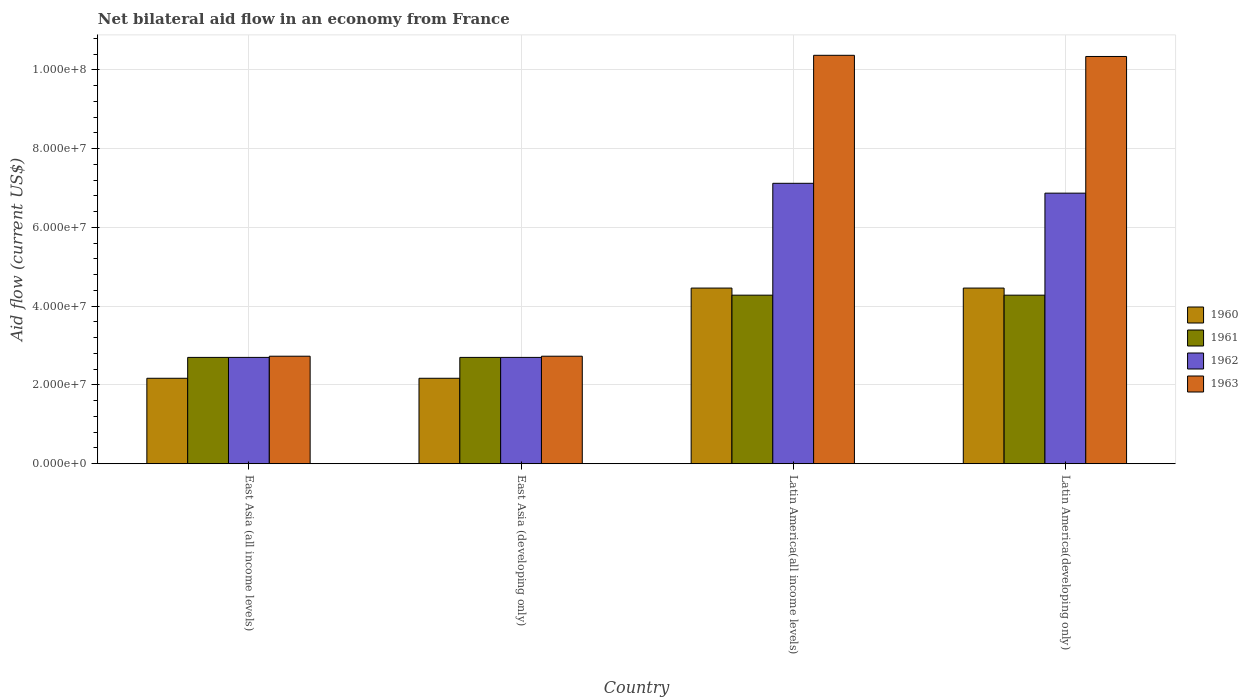How many different coloured bars are there?
Keep it short and to the point. 4. How many groups of bars are there?
Your answer should be compact. 4. Are the number of bars per tick equal to the number of legend labels?
Keep it short and to the point. Yes. How many bars are there on the 3rd tick from the left?
Offer a very short reply. 4. How many bars are there on the 4th tick from the right?
Your response must be concise. 4. What is the label of the 1st group of bars from the left?
Your answer should be very brief. East Asia (all income levels). In how many cases, is the number of bars for a given country not equal to the number of legend labels?
Offer a terse response. 0. What is the net bilateral aid flow in 1963 in Latin America(all income levels)?
Give a very brief answer. 1.04e+08. Across all countries, what is the maximum net bilateral aid flow in 1963?
Your answer should be very brief. 1.04e+08. Across all countries, what is the minimum net bilateral aid flow in 1962?
Your answer should be compact. 2.70e+07. In which country was the net bilateral aid flow in 1960 maximum?
Offer a terse response. Latin America(all income levels). In which country was the net bilateral aid flow in 1960 minimum?
Your answer should be very brief. East Asia (all income levels). What is the total net bilateral aid flow in 1961 in the graph?
Provide a succinct answer. 1.40e+08. What is the difference between the net bilateral aid flow in 1963 in East Asia (developing only) and that in Latin America(all income levels)?
Offer a very short reply. -7.64e+07. What is the difference between the net bilateral aid flow in 1960 in East Asia (developing only) and the net bilateral aid flow in 1961 in Latin America(developing only)?
Give a very brief answer. -2.11e+07. What is the average net bilateral aid flow in 1961 per country?
Your answer should be very brief. 3.49e+07. What is the difference between the net bilateral aid flow of/in 1960 and net bilateral aid flow of/in 1961 in Latin America(developing only)?
Provide a succinct answer. 1.80e+06. In how many countries, is the net bilateral aid flow in 1960 greater than 32000000 US$?
Provide a short and direct response. 2. What is the ratio of the net bilateral aid flow in 1960 in East Asia (developing only) to that in Latin America(all income levels)?
Your response must be concise. 0.49. Is the net bilateral aid flow in 1960 in East Asia (all income levels) less than that in Latin America(developing only)?
Make the answer very short. Yes. What is the difference between the highest and the second highest net bilateral aid flow in 1961?
Make the answer very short. 1.58e+07. What is the difference between the highest and the lowest net bilateral aid flow in 1963?
Offer a terse response. 7.64e+07. Is the sum of the net bilateral aid flow in 1960 in East Asia (developing only) and Latin America(all income levels) greater than the maximum net bilateral aid flow in 1962 across all countries?
Keep it short and to the point. No. Is it the case that in every country, the sum of the net bilateral aid flow in 1963 and net bilateral aid flow in 1962 is greater than the net bilateral aid flow in 1960?
Your response must be concise. Yes. Are all the bars in the graph horizontal?
Your response must be concise. No. How many countries are there in the graph?
Offer a terse response. 4. Are the values on the major ticks of Y-axis written in scientific E-notation?
Offer a terse response. Yes. Does the graph contain grids?
Your response must be concise. Yes. Where does the legend appear in the graph?
Provide a short and direct response. Center right. How many legend labels are there?
Keep it short and to the point. 4. What is the title of the graph?
Provide a succinct answer. Net bilateral aid flow in an economy from France. What is the label or title of the X-axis?
Ensure brevity in your answer.  Country. What is the Aid flow (current US$) in 1960 in East Asia (all income levels)?
Provide a succinct answer. 2.17e+07. What is the Aid flow (current US$) in 1961 in East Asia (all income levels)?
Provide a succinct answer. 2.70e+07. What is the Aid flow (current US$) of 1962 in East Asia (all income levels)?
Keep it short and to the point. 2.70e+07. What is the Aid flow (current US$) in 1963 in East Asia (all income levels)?
Provide a succinct answer. 2.73e+07. What is the Aid flow (current US$) in 1960 in East Asia (developing only)?
Offer a very short reply. 2.17e+07. What is the Aid flow (current US$) in 1961 in East Asia (developing only)?
Provide a short and direct response. 2.70e+07. What is the Aid flow (current US$) in 1962 in East Asia (developing only)?
Provide a short and direct response. 2.70e+07. What is the Aid flow (current US$) of 1963 in East Asia (developing only)?
Provide a succinct answer. 2.73e+07. What is the Aid flow (current US$) in 1960 in Latin America(all income levels)?
Offer a terse response. 4.46e+07. What is the Aid flow (current US$) of 1961 in Latin America(all income levels)?
Offer a terse response. 4.28e+07. What is the Aid flow (current US$) in 1962 in Latin America(all income levels)?
Make the answer very short. 7.12e+07. What is the Aid flow (current US$) of 1963 in Latin America(all income levels)?
Ensure brevity in your answer.  1.04e+08. What is the Aid flow (current US$) of 1960 in Latin America(developing only)?
Your response must be concise. 4.46e+07. What is the Aid flow (current US$) of 1961 in Latin America(developing only)?
Your response must be concise. 4.28e+07. What is the Aid flow (current US$) in 1962 in Latin America(developing only)?
Provide a short and direct response. 6.87e+07. What is the Aid flow (current US$) in 1963 in Latin America(developing only)?
Give a very brief answer. 1.03e+08. Across all countries, what is the maximum Aid flow (current US$) in 1960?
Your answer should be very brief. 4.46e+07. Across all countries, what is the maximum Aid flow (current US$) in 1961?
Provide a succinct answer. 4.28e+07. Across all countries, what is the maximum Aid flow (current US$) in 1962?
Provide a succinct answer. 7.12e+07. Across all countries, what is the maximum Aid flow (current US$) of 1963?
Give a very brief answer. 1.04e+08. Across all countries, what is the minimum Aid flow (current US$) of 1960?
Your response must be concise. 2.17e+07. Across all countries, what is the minimum Aid flow (current US$) of 1961?
Ensure brevity in your answer.  2.70e+07. Across all countries, what is the minimum Aid flow (current US$) of 1962?
Provide a short and direct response. 2.70e+07. Across all countries, what is the minimum Aid flow (current US$) of 1963?
Make the answer very short. 2.73e+07. What is the total Aid flow (current US$) in 1960 in the graph?
Provide a succinct answer. 1.33e+08. What is the total Aid flow (current US$) in 1961 in the graph?
Offer a very short reply. 1.40e+08. What is the total Aid flow (current US$) in 1962 in the graph?
Keep it short and to the point. 1.94e+08. What is the total Aid flow (current US$) of 1963 in the graph?
Give a very brief answer. 2.62e+08. What is the difference between the Aid flow (current US$) in 1961 in East Asia (all income levels) and that in East Asia (developing only)?
Your answer should be compact. 0. What is the difference between the Aid flow (current US$) of 1962 in East Asia (all income levels) and that in East Asia (developing only)?
Your response must be concise. 0. What is the difference between the Aid flow (current US$) of 1963 in East Asia (all income levels) and that in East Asia (developing only)?
Your answer should be very brief. 0. What is the difference between the Aid flow (current US$) of 1960 in East Asia (all income levels) and that in Latin America(all income levels)?
Ensure brevity in your answer.  -2.29e+07. What is the difference between the Aid flow (current US$) in 1961 in East Asia (all income levels) and that in Latin America(all income levels)?
Offer a very short reply. -1.58e+07. What is the difference between the Aid flow (current US$) in 1962 in East Asia (all income levels) and that in Latin America(all income levels)?
Ensure brevity in your answer.  -4.42e+07. What is the difference between the Aid flow (current US$) in 1963 in East Asia (all income levels) and that in Latin America(all income levels)?
Keep it short and to the point. -7.64e+07. What is the difference between the Aid flow (current US$) of 1960 in East Asia (all income levels) and that in Latin America(developing only)?
Keep it short and to the point. -2.29e+07. What is the difference between the Aid flow (current US$) of 1961 in East Asia (all income levels) and that in Latin America(developing only)?
Give a very brief answer. -1.58e+07. What is the difference between the Aid flow (current US$) of 1962 in East Asia (all income levels) and that in Latin America(developing only)?
Make the answer very short. -4.17e+07. What is the difference between the Aid flow (current US$) of 1963 in East Asia (all income levels) and that in Latin America(developing only)?
Ensure brevity in your answer.  -7.61e+07. What is the difference between the Aid flow (current US$) of 1960 in East Asia (developing only) and that in Latin America(all income levels)?
Provide a succinct answer. -2.29e+07. What is the difference between the Aid flow (current US$) in 1961 in East Asia (developing only) and that in Latin America(all income levels)?
Your answer should be very brief. -1.58e+07. What is the difference between the Aid flow (current US$) in 1962 in East Asia (developing only) and that in Latin America(all income levels)?
Your answer should be very brief. -4.42e+07. What is the difference between the Aid flow (current US$) in 1963 in East Asia (developing only) and that in Latin America(all income levels)?
Provide a short and direct response. -7.64e+07. What is the difference between the Aid flow (current US$) in 1960 in East Asia (developing only) and that in Latin America(developing only)?
Give a very brief answer. -2.29e+07. What is the difference between the Aid flow (current US$) in 1961 in East Asia (developing only) and that in Latin America(developing only)?
Ensure brevity in your answer.  -1.58e+07. What is the difference between the Aid flow (current US$) of 1962 in East Asia (developing only) and that in Latin America(developing only)?
Your response must be concise. -4.17e+07. What is the difference between the Aid flow (current US$) in 1963 in East Asia (developing only) and that in Latin America(developing only)?
Offer a very short reply. -7.61e+07. What is the difference between the Aid flow (current US$) in 1960 in Latin America(all income levels) and that in Latin America(developing only)?
Provide a succinct answer. 0. What is the difference between the Aid flow (current US$) in 1961 in Latin America(all income levels) and that in Latin America(developing only)?
Make the answer very short. 0. What is the difference between the Aid flow (current US$) in 1962 in Latin America(all income levels) and that in Latin America(developing only)?
Make the answer very short. 2.50e+06. What is the difference between the Aid flow (current US$) in 1960 in East Asia (all income levels) and the Aid flow (current US$) in 1961 in East Asia (developing only)?
Give a very brief answer. -5.30e+06. What is the difference between the Aid flow (current US$) in 1960 in East Asia (all income levels) and the Aid flow (current US$) in 1962 in East Asia (developing only)?
Provide a short and direct response. -5.30e+06. What is the difference between the Aid flow (current US$) in 1960 in East Asia (all income levels) and the Aid flow (current US$) in 1963 in East Asia (developing only)?
Your answer should be very brief. -5.60e+06. What is the difference between the Aid flow (current US$) of 1961 in East Asia (all income levels) and the Aid flow (current US$) of 1962 in East Asia (developing only)?
Your answer should be compact. 0. What is the difference between the Aid flow (current US$) of 1961 in East Asia (all income levels) and the Aid flow (current US$) of 1963 in East Asia (developing only)?
Provide a short and direct response. -3.00e+05. What is the difference between the Aid flow (current US$) of 1960 in East Asia (all income levels) and the Aid flow (current US$) of 1961 in Latin America(all income levels)?
Ensure brevity in your answer.  -2.11e+07. What is the difference between the Aid flow (current US$) of 1960 in East Asia (all income levels) and the Aid flow (current US$) of 1962 in Latin America(all income levels)?
Offer a very short reply. -4.95e+07. What is the difference between the Aid flow (current US$) in 1960 in East Asia (all income levels) and the Aid flow (current US$) in 1963 in Latin America(all income levels)?
Make the answer very short. -8.20e+07. What is the difference between the Aid flow (current US$) of 1961 in East Asia (all income levels) and the Aid flow (current US$) of 1962 in Latin America(all income levels)?
Your answer should be compact. -4.42e+07. What is the difference between the Aid flow (current US$) in 1961 in East Asia (all income levels) and the Aid flow (current US$) in 1963 in Latin America(all income levels)?
Your answer should be compact. -7.67e+07. What is the difference between the Aid flow (current US$) of 1962 in East Asia (all income levels) and the Aid flow (current US$) of 1963 in Latin America(all income levels)?
Ensure brevity in your answer.  -7.67e+07. What is the difference between the Aid flow (current US$) in 1960 in East Asia (all income levels) and the Aid flow (current US$) in 1961 in Latin America(developing only)?
Your answer should be very brief. -2.11e+07. What is the difference between the Aid flow (current US$) of 1960 in East Asia (all income levels) and the Aid flow (current US$) of 1962 in Latin America(developing only)?
Your answer should be very brief. -4.70e+07. What is the difference between the Aid flow (current US$) in 1960 in East Asia (all income levels) and the Aid flow (current US$) in 1963 in Latin America(developing only)?
Provide a short and direct response. -8.17e+07. What is the difference between the Aid flow (current US$) in 1961 in East Asia (all income levels) and the Aid flow (current US$) in 1962 in Latin America(developing only)?
Provide a succinct answer. -4.17e+07. What is the difference between the Aid flow (current US$) in 1961 in East Asia (all income levels) and the Aid flow (current US$) in 1963 in Latin America(developing only)?
Provide a short and direct response. -7.64e+07. What is the difference between the Aid flow (current US$) of 1962 in East Asia (all income levels) and the Aid flow (current US$) of 1963 in Latin America(developing only)?
Your response must be concise. -7.64e+07. What is the difference between the Aid flow (current US$) of 1960 in East Asia (developing only) and the Aid flow (current US$) of 1961 in Latin America(all income levels)?
Provide a succinct answer. -2.11e+07. What is the difference between the Aid flow (current US$) of 1960 in East Asia (developing only) and the Aid flow (current US$) of 1962 in Latin America(all income levels)?
Keep it short and to the point. -4.95e+07. What is the difference between the Aid flow (current US$) of 1960 in East Asia (developing only) and the Aid flow (current US$) of 1963 in Latin America(all income levels)?
Provide a short and direct response. -8.20e+07. What is the difference between the Aid flow (current US$) of 1961 in East Asia (developing only) and the Aid flow (current US$) of 1962 in Latin America(all income levels)?
Provide a short and direct response. -4.42e+07. What is the difference between the Aid flow (current US$) in 1961 in East Asia (developing only) and the Aid flow (current US$) in 1963 in Latin America(all income levels)?
Make the answer very short. -7.67e+07. What is the difference between the Aid flow (current US$) of 1962 in East Asia (developing only) and the Aid flow (current US$) of 1963 in Latin America(all income levels)?
Give a very brief answer. -7.67e+07. What is the difference between the Aid flow (current US$) of 1960 in East Asia (developing only) and the Aid flow (current US$) of 1961 in Latin America(developing only)?
Offer a very short reply. -2.11e+07. What is the difference between the Aid flow (current US$) of 1960 in East Asia (developing only) and the Aid flow (current US$) of 1962 in Latin America(developing only)?
Provide a succinct answer. -4.70e+07. What is the difference between the Aid flow (current US$) of 1960 in East Asia (developing only) and the Aid flow (current US$) of 1963 in Latin America(developing only)?
Ensure brevity in your answer.  -8.17e+07. What is the difference between the Aid flow (current US$) of 1961 in East Asia (developing only) and the Aid flow (current US$) of 1962 in Latin America(developing only)?
Make the answer very short. -4.17e+07. What is the difference between the Aid flow (current US$) of 1961 in East Asia (developing only) and the Aid flow (current US$) of 1963 in Latin America(developing only)?
Offer a terse response. -7.64e+07. What is the difference between the Aid flow (current US$) of 1962 in East Asia (developing only) and the Aid flow (current US$) of 1963 in Latin America(developing only)?
Keep it short and to the point. -7.64e+07. What is the difference between the Aid flow (current US$) in 1960 in Latin America(all income levels) and the Aid flow (current US$) in 1961 in Latin America(developing only)?
Your answer should be very brief. 1.80e+06. What is the difference between the Aid flow (current US$) in 1960 in Latin America(all income levels) and the Aid flow (current US$) in 1962 in Latin America(developing only)?
Your response must be concise. -2.41e+07. What is the difference between the Aid flow (current US$) in 1960 in Latin America(all income levels) and the Aid flow (current US$) in 1963 in Latin America(developing only)?
Keep it short and to the point. -5.88e+07. What is the difference between the Aid flow (current US$) in 1961 in Latin America(all income levels) and the Aid flow (current US$) in 1962 in Latin America(developing only)?
Give a very brief answer. -2.59e+07. What is the difference between the Aid flow (current US$) of 1961 in Latin America(all income levels) and the Aid flow (current US$) of 1963 in Latin America(developing only)?
Provide a short and direct response. -6.06e+07. What is the difference between the Aid flow (current US$) in 1962 in Latin America(all income levels) and the Aid flow (current US$) in 1963 in Latin America(developing only)?
Keep it short and to the point. -3.22e+07. What is the average Aid flow (current US$) in 1960 per country?
Your answer should be compact. 3.32e+07. What is the average Aid flow (current US$) of 1961 per country?
Give a very brief answer. 3.49e+07. What is the average Aid flow (current US$) of 1962 per country?
Give a very brief answer. 4.85e+07. What is the average Aid flow (current US$) in 1963 per country?
Ensure brevity in your answer.  6.54e+07. What is the difference between the Aid flow (current US$) in 1960 and Aid flow (current US$) in 1961 in East Asia (all income levels)?
Make the answer very short. -5.30e+06. What is the difference between the Aid flow (current US$) of 1960 and Aid flow (current US$) of 1962 in East Asia (all income levels)?
Your answer should be compact. -5.30e+06. What is the difference between the Aid flow (current US$) in 1960 and Aid flow (current US$) in 1963 in East Asia (all income levels)?
Make the answer very short. -5.60e+06. What is the difference between the Aid flow (current US$) in 1961 and Aid flow (current US$) in 1962 in East Asia (all income levels)?
Your answer should be very brief. 0. What is the difference between the Aid flow (current US$) in 1961 and Aid flow (current US$) in 1963 in East Asia (all income levels)?
Offer a terse response. -3.00e+05. What is the difference between the Aid flow (current US$) of 1960 and Aid flow (current US$) of 1961 in East Asia (developing only)?
Give a very brief answer. -5.30e+06. What is the difference between the Aid flow (current US$) in 1960 and Aid flow (current US$) in 1962 in East Asia (developing only)?
Your response must be concise. -5.30e+06. What is the difference between the Aid flow (current US$) in 1960 and Aid flow (current US$) in 1963 in East Asia (developing only)?
Your response must be concise. -5.60e+06. What is the difference between the Aid flow (current US$) of 1961 and Aid flow (current US$) of 1962 in East Asia (developing only)?
Give a very brief answer. 0. What is the difference between the Aid flow (current US$) of 1962 and Aid flow (current US$) of 1963 in East Asia (developing only)?
Your answer should be compact. -3.00e+05. What is the difference between the Aid flow (current US$) in 1960 and Aid flow (current US$) in 1961 in Latin America(all income levels)?
Offer a terse response. 1.80e+06. What is the difference between the Aid flow (current US$) of 1960 and Aid flow (current US$) of 1962 in Latin America(all income levels)?
Make the answer very short. -2.66e+07. What is the difference between the Aid flow (current US$) of 1960 and Aid flow (current US$) of 1963 in Latin America(all income levels)?
Your answer should be very brief. -5.91e+07. What is the difference between the Aid flow (current US$) of 1961 and Aid flow (current US$) of 1962 in Latin America(all income levels)?
Keep it short and to the point. -2.84e+07. What is the difference between the Aid flow (current US$) in 1961 and Aid flow (current US$) in 1963 in Latin America(all income levels)?
Provide a short and direct response. -6.09e+07. What is the difference between the Aid flow (current US$) of 1962 and Aid flow (current US$) of 1963 in Latin America(all income levels)?
Provide a short and direct response. -3.25e+07. What is the difference between the Aid flow (current US$) of 1960 and Aid flow (current US$) of 1961 in Latin America(developing only)?
Offer a very short reply. 1.80e+06. What is the difference between the Aid flow (current US$) of 1960 and Aid flow (current US$) of 1962 in Latin America(developing only)?
Your response must be concise. -2.41e+07. What is the difference between the Aid flow (current US$) of 1960 and Aid flow (current US$) of 1963 in Latin America(developing only)?
Keep it short and to the point. -5.88e+07. What is the difference between the Aid flow (current US$) of 1961 and Aid flow (current US$) of 1962 in Latin America(developing only)?
Keep it short and to the point. -2.59e+07. What is the difference between the Aid flow (current US$) of 1961 and Aid flow (current US$) of 1963 in Latin America(developing only)?
Offer a very short reply. -6.06e+07. What is the difference between the Aid flow (current US$) of 1962 and Aid flow (current US$) of 1963 in Latin America(developing only)?
Your answer should be compact. -3.47e+07. What is the ratio of the Aid flow (current US$) of 1961 in East Asia (all income levels) to that in East Asia (developing only)?
Your answer should be compact. 1. What is the ratio of the Aid flow (current US$) of 1963 in East Asia (all income levels) to that in East Asia (developing only)?
Offer a very short reply. 1. What is the ratio of the Aid flow (current US$) of 1960 in East Asia (all income levels) to that in Latin America(all income levels)?
Provide a short and direct response. 0.49. What is the ratio of the Aid flow (current US$) of 1961 in East Asia (all income levels) to that in Latin America(all income levels)?
Offer a terse response. 0.63. What is the ratio of the Aid flow (current US$) of 1962 in East Asia (all income levels) to that in Latin America(all income levels)?
Make the answer very short. 0.38. What is the ratio of the Aid flow (current US$) in 1963 in East Asia (all income levels) to that in Latin America(all income levels)?
Keep it short and to the point. 0.26. What is the ratio of the Aid flow (current US$) in 1960 in East Asia (all income levels) to that in Latin America(developing only)?
Provide a short and direct response. 0.49. What is the ratio of the Aid flow (current US$) in 1961 in East Asia (all income levels) to that in Latin America(developing only)?
Ensure brevity in your answer.  0.63. What is the ratio of the Aid flow (current US$) in 1962 in East Asia (all income levels) to that in Latin America(developing only)?
Give a very brief answer. 0.39. What is the ratio of the Aid flow (current US$) in 1963 in East Asia (all income levels) to that in Latin America(developing only)?
Your answer should be compact. 0.26. What is the ratio of the Aid flow (current US$) of 1960 in East Asia (developing only) to that in Latin America(all income levels)?
Provide a short and direct response. 0.49. What is the ratio of the Aid flow (current US$) of 1961 in East Asia (developing only) to that in Latin America(all income levels)?
Your response must be concise. 0.63. What is the ratio of the Aid flow (current US$) in 1962 in East Asia (developing only) to that in Latin America(all income levels)?
Provide a succinct answer. 0.38. What is the ratio of the Aid flow (current US$) of 1963 in East Asia (developing only) to that in Latin America(all income levels)?
Offer a terse response. 0.26. What is the ratio of the Aid flow (current US$) in 1960 in East Asia (developing only) to that in Latin America(developing only)?
Your response must be concise. 0.49. What is the ratio of the Aid flow (current US$) in 1961 in East Asia (developing only) to that in Latin America(developing only)?
Provide a succinct answer. 0.63. What is the ratio of the Aid flow (current US$) of 1962 in East Asia (developing only) to that in Latin America(developing only)?
Offer a very short reply. 0.39. What is the ratio of the Aid flow (current US$) in 1963 in East Asia (developing only) to that in Latin America(developing only)?
Give a very brief answer. 0.26. What is the ratio of the Aid flow (current US$) of 1962 in Latin America(all income levels) to that in Latin America(developing only)?
Provide a succinct answer. 1.04. What is the difference between the highest and the second highest Aid flow (current US$) in 1962?
Your response must be concise. 2.50e+06. What is the difference between the highest and the second highest Aid flow (current US$) in 1963?
Your answer should be compact. 3.00e+05. What is the difference between the highest and the lowest Aid flow (current US$) of 1960?
Your response must be concise. 2.29e+07. What is the difference between the highest and the lowest Aid flow (current US$) of 1961?
Keep it short and to the point. 1.58e+07. What is the difference between the highest and the lowest Aid flow (current US$) in 1962?
Give a very brief answer. 4.42e+07. What is the difference between the highest and the lowest Aid flow (current US$) of 1963?
Offer a terse response. 7.64e+07. 